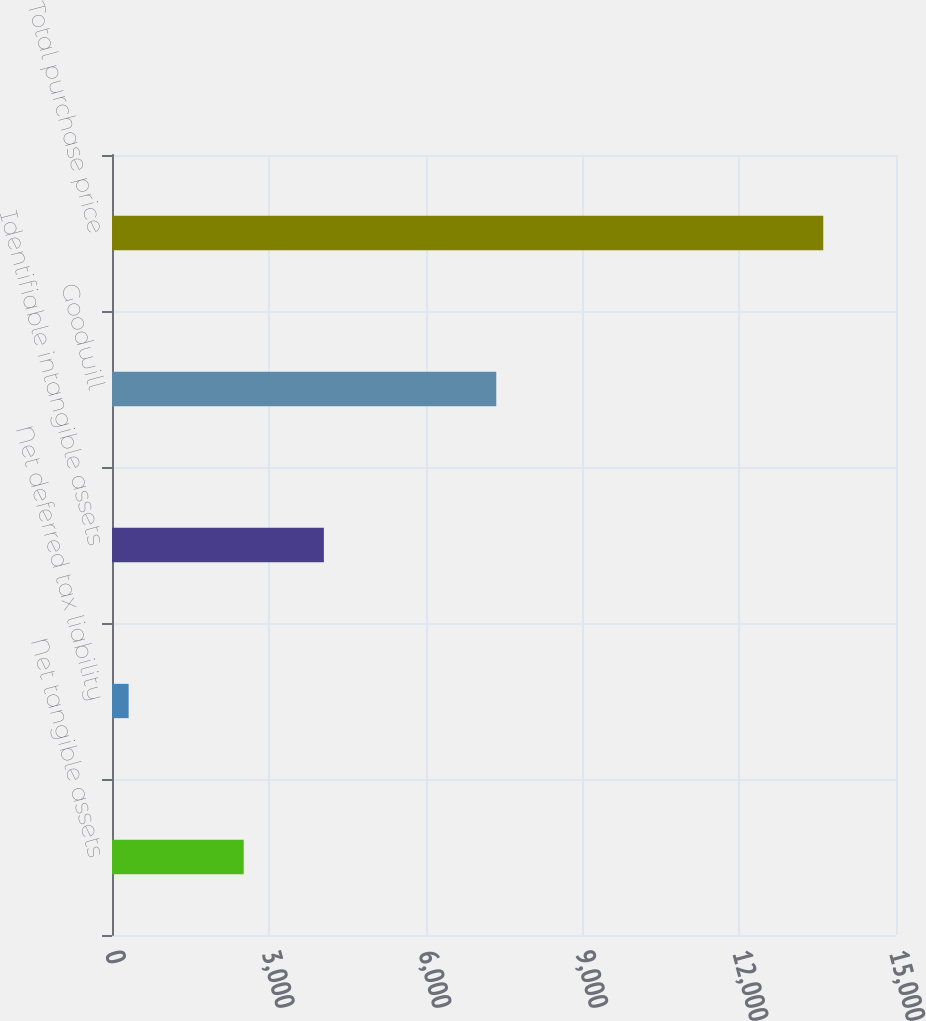<chart> <loc_0><loc_0><loc_500><loc_500><bar_chart><fcel>Net tangible assets<fcel>Net deferred tax liability<fcel>Identifiable intangible assets<fcel>Goodwill<fcel>Total purchase price<nl><fcel>2520<fcel>318<fcel>4054<fcel>7352<fcel>13608<nl></chart> 